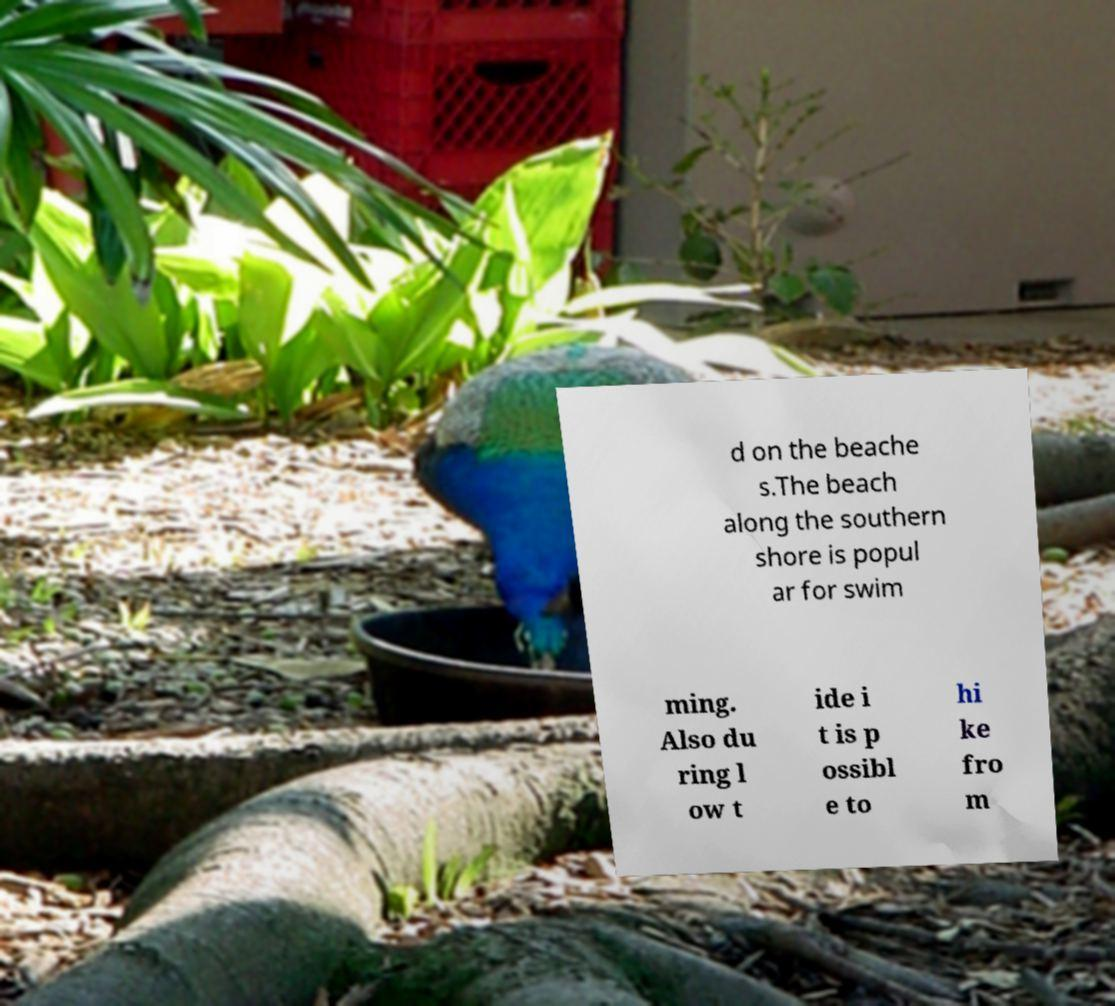Could you assist in decoding the text presented in this image and type it out clearly? d on the beache s.The beach along the southern shore is popul ar for swim ming. Also du ring l ow t ide i t is p ossibl e to hi ke fro m 